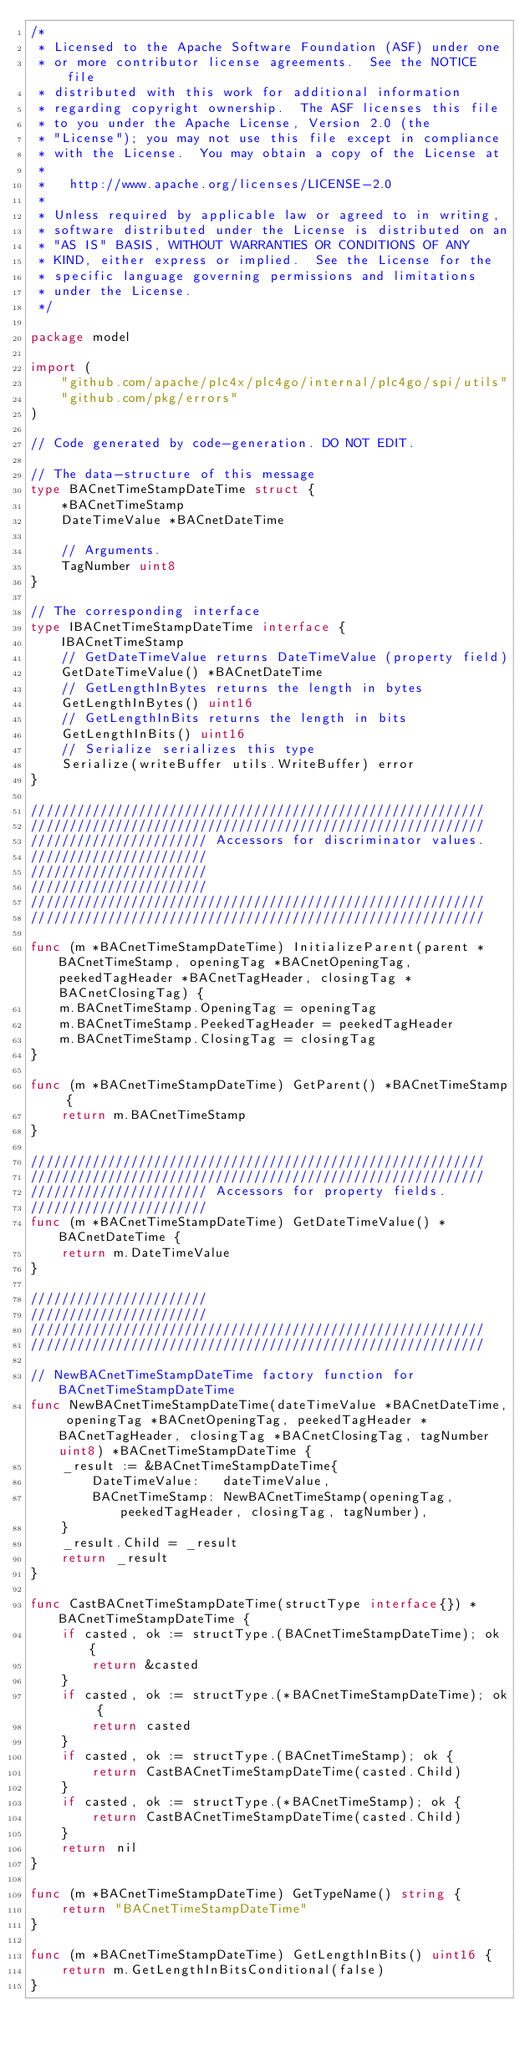<code> <loc_0><loc_0><loc_500><loc_500><_Go_>/*
 * Licensed to the Apache Software Foundation (ASF) under one
 * or more contributor license agreements.  See the NOTICE file
 * distributed with this work for additional information
 * regarding copyright ownership.  The ASF licenses this file
 * to you under the Apache License, Version 2.0 (the
 * "License"); you may not use this file except in compliance
 * with the License.  You may obtain a copy of the License at
 *
 *   http://www.apache.org/licenses/LICENSE-2.0
 *
 * Unless required by applicable law or agreed to in writing,
 * software distributed under the License is distributed on an
 * "AS IS" BASIS, WITHOUT WARRANTIES OR CONDITIONS OF ANY
 * KIND, either express or implied.  See the License for the
 * specific language governing permissions and limitations
 * under the License.
 */

package model

import (
	"github.com/apache/plc4x/plc4go/internal/plc4go/spi/utils"
	"github.com/pkg/errors"
)

// Code generated by code-generation. DO NOT EDIT.

// The data-structure of this message
type BACnetTimeStampDateTime struct {
	*BACnetTimeStamp
	DateTimeValue *BACnetDateTime

	// Arguments.
	TagNumber uint8
}

// The corresponding interface
type IBACnetTimeStampDateTime interface {
	IBACnetTimeStamp
	// GetDateTimeValue returns DateTimeValue (property field)
	GetDateTimeValue() *BACnetDateTime
	// GetLengthInBytes returns the length in bytes
	GetLengthInBytes() uint16
	// GetLengthInBits returns the length in bits
	GetLengthInBits() uint16
	// Serialize serializes this type
	Serialize(writeBuffer utils.WriteBuffer) error
}

///////////////////////////////////////////////////////////
///////////////////////////////////////////////////////////
/////////////////////// Accessors for discriminator values.
///////////////////////
///////////////////////
///////////////////////
///////////////////////////////////////////////////////////
///////////////////////////////////////////////////////////

func (m *BACnetTimeStampDateTime) InitializeParent(parent *BACnetTimeStamp, openingTag *BACnetOpeningTag, peekedTagHeader *BACnetTagHeader, closingTag *BACnetClosingTag) {
	m.BACnetTimeStamp.OpeningTag = openingTag
	m.BACnetTimeStamp.PeekedTagHeader = peekedTagHeader
	m.BACnetTimeStamp.ClosingTag = closingTag
}

func (m *BACnetTimeStampDateTime) GetParent() *BACnetTimeStamp {
	return m.BACnetTimeStamp
}

///////////////////////////////////////////////////////////
///////////////////////////////////////////////////////////
/////////////////////// Accessors for property fields.
///////////////////////
func (m *BACnetTimeStampDateTime) GetDateTimeValue() *BACnetDateTime {
	return m.DateTimeValue
}

///////////////////////
///////////////////////
///////////////////////////////////////////////////////////
///////////////////////////////////////////////////////////

// NewBACnetTimeStampDateTime factory function for BACnetTimeStampDateTime
func NewBACnetTimeStampDateTime(dateTimeValue *BACnetDateTime, openingTag *BACnetOpeningTag, peekedTagHeader *BACnetTagHeader, closingTag *BACnetClosingTag, tagNumber uint8) *BACnetTimeStampDateTime {
	_result := &BACnetTimeStampDateTime{
		DateTimeValue:   dateTimeValue,
		BACnetTimeStamp: NewBACnetTimeStamp(openingTag, peekedTagHeader, closingTag, tagNumber),
	}
	_result.Child = _result
	return _result
}

func CastBACnetTimeStampDateTime(structType interface{}) *BACnetTimeStampDateTime {
	if casted, ok := structType.(BACnetTimeStampDateTime); ok {
		return &casted
	}
	if casted, ok := structType.(*BACnetTimeStampDateTime); ok {
		return casted
	}
	if casted, ok := structType.(BACnetTimeStamp); ok {
		return CastBACnetTimeStampDateTime(casted.Child)
	}
	if casted, ok := structType.(*BACnetTimeStamp); ok {
		return CastBACnetTimeStampDateTime(casted.Child)
	}
	return nil
}

func (m *BACnetTimeStampDateTime) GetTypeName() string {
	return "BACnetTimeStampDateTime"
}

func (m *BACnetTimeStampDateTime) GetLengthInBits() uint16 {
	return m.GetLengthInBitsConditional(false)
}
</code> 